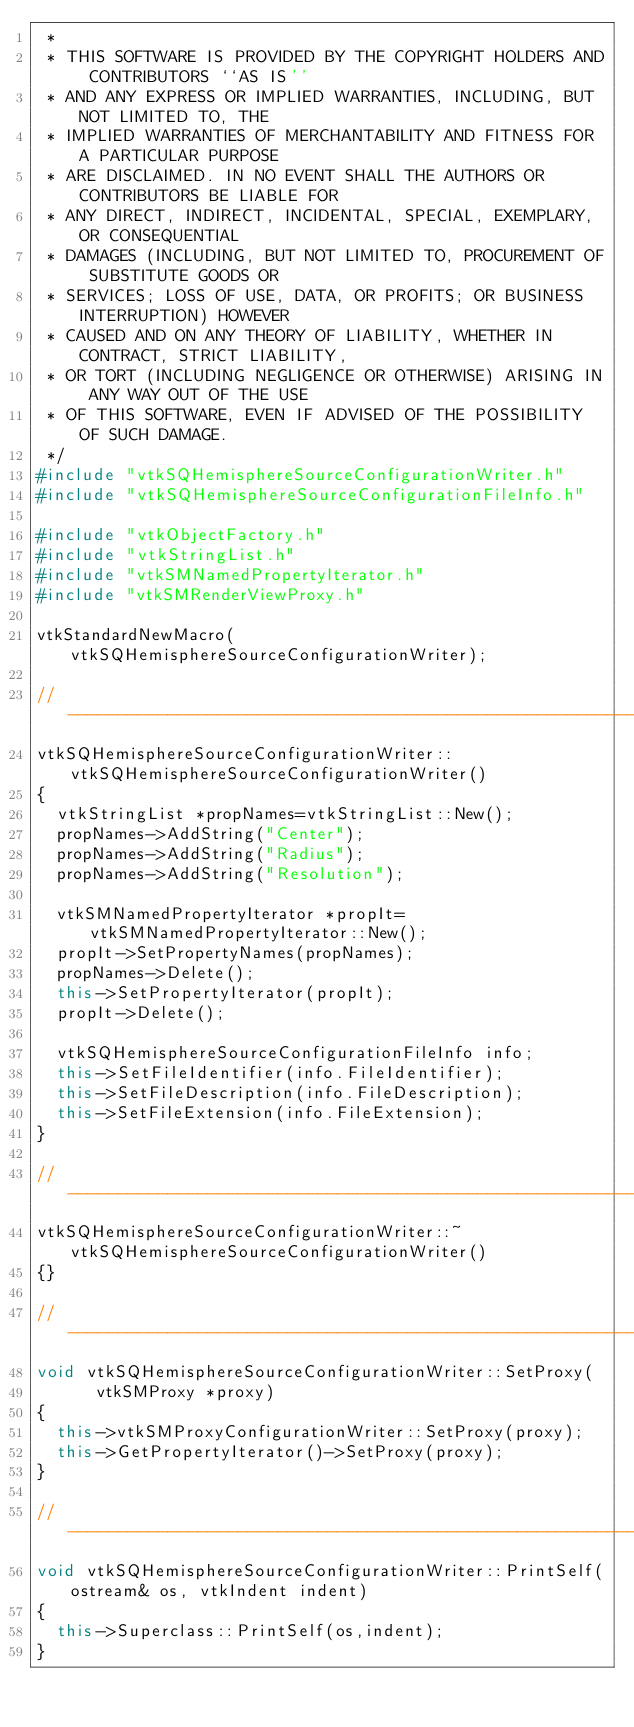Convert code to text. <code><loc_0><loc_0><loc_500><loc_500><_C++_> *
 * THIS SOFTWARE IS PROVIDED BY THE COPYRIGHT HOLDERS AND CONTRIBUTORS ``AS IS''
 * AND ANY EXPRESS OR IMPLIED WARRANTIES, INCLUDING, BUT NOT LIMITED TO, THE
 * IMPLIED WARRANTIES OF MERCHANTABILITY AND FITNESS FOR A PARTICULAR PURPOSE
 * ARE DISCLAIMED. IN NO EVENT SHALL THE AUTHORS OR CONTRIBUTORS BE LIABLE FOR
 * ANY DIRECT, INDIRECT, INCIDENTAL, SPECIAL, EXEMPLARY, OR CONSEQUENTIAL
 * DAMAGES (INCLUDING, BUT NOT LIMITED TO, PROCUREMENT OF SUBSTITUTE GOODS OR
 * SERVICES; LOSS OF USE, DATA, OR PROFITS; OR BUSINESS INTERRUPTION) HOWEVER
 * CAUSED AND ON ANY THEORY OF LIABILITY, WHETHER IN CONTRACT, STRICT LIABILITY,
 * OR TORT (INCLUDING NEGLIGENCE OR OTHERWISE) ARISING IN ANY WAY OUT OF THE USE
 * OF THIS SOFTWARE, EVEN IF ADVISED OF THE POSSIBILITY OF SUCH DAMAGE.
 */
#include "vtkSQHemisphereSourceConfigurationWriter.h"
#include "vtkSQHemisphereSourceConfigurationFileInfo.h"

#include "vtkObjectFactory.h"
#include "vtkStringList.h"
#include "vtkSMNamedPropertyIterator.h"
#include "vtkSMRenderViewProxy.h"

vtkStandardNewMacro(vtkSQHemisphereSourceConfigurationWriter);

//-----------------------------------------------------------------------------
vtkSQHemisphereSourceConfigurationWriter::vtkSQHemisphereSourceConfigurationWriter()
{
  vtkStringList *propNames=vtkStringList::New();
  propNames->AddString("Center");
  propNames->AddString("Radius");
  propNames->AddString("Resolution");

  vtkSMNamedPropertyIterator *propIt=vtkSMNamedPropertyIterator::New();
  propIt->SetPropertyNames(propNames);
  propNames->Delete();
  this->SetPropertyIterator(propIt);
  propIt->Delete();

  vtkSQHemisphereSourceConfigurationFileInfo info;
  this->SetFileIdentifier(info.FileIdentifier);
  this->SetFileDescription(info.FileDescription);
  this->SetFileExtension(info.FileExtension);
}

//-----------------------------------------------------------------------------
vtkSQHemisphereSourceConfigurationWriter::~vtkSQHemisphereSourceConfigurationWriter()
{}

//-----------------------------------------------------------------------------
void vtkSQHemisphereSourceConfigurationWriter::SetProxy(
      vtkSMProxy *proxy)
{
  this->vtkSMProxyConfigurationWriter::SetProxy(proxy);
  this->GetPropertyIterator()->SetProxy(proxy);
}

//-----------------------------------------------------------------------------
void vtkSQHemisphereSourceConfigurationWriter::PrintSelf(ostream& os, vtkIndent indent)
{
  this->Superclass::PrintSelf(os,indent);
}
</code> 